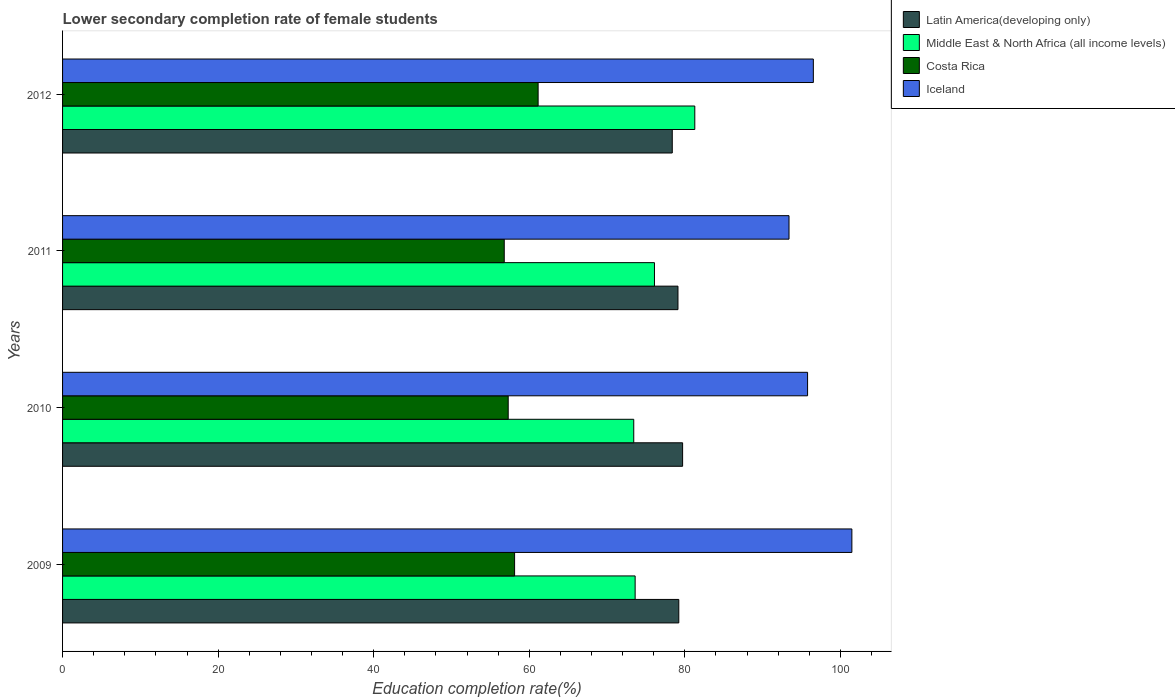How many different coloured bars are there?
Your answer should be compact. 4. How many groups of bars are there?
Make the answer very short. 4. Are the number of bars per tick equal to the number of legend labels?
Your response must be concise. Yes. Are the number of bars on each tick of the Y-axis equal?
Keep it short and to the point. Yes. How many bars are there on the 4th tick from the bottom?
Offer a very short reply. 4. What is the lower secondary completion rate of female students in Middle East & North Africa (all income levels) in 2011?
Ensure brevity in your answer.  76.1. Across all years, what is the maximum lower secondary completion rate of female students in Middle East & North Africa (all income levels)?
Make the answer very short. 81.29. Across all years, what is the minimum lower secondary completion rate of female students in Middle East & North Africa (all income levels)?
Your response must be concise. 73.44. In which year was the lower secondary completion rate of female students in Costa Rica maximum?
Offer a very short reply. 2012. In which year was the lower secondary completion rate of female students in Costa Rica minimum?
Offer a very short reply. 2011. What is the total lower secondary completion rate of female students in Costa Rica in the graph?
Offer a terse response. 233.34. What is the difference between the lower secondary completion rate of female students in Iceland in 2010 and that in 2012?
Provide a short and direct response. -0.74. What is the difference between the lower secondary completion rate of female students in Latin America(developing only) in 2010 and the lower secondary completion rate of female students in Costa Rica in 2011?
Provide a short and direct response. 22.93. What is the average lower secondary completion rate of female students in Iceland per year?
Ensure brevity in your answer.  96.8. In the year 2012, what is the difference between the lower secondary completion rate of female students in Latin America(developing only) and lower secondary completion rate of female students in Iceland?
Offer a very short reply. -18.14. What is the ratio of the lower secondary completion rate of female students in Latin America(developing only) in 2011 to that in 2012?
Provide a short and direct response. 1.01. Is the lower secondary completion rate of female students in Costa Rica in 2010 less than that in 2011?
Your answer should be compact. No. What is the difference between the highest and the second highest lower secondary completion rate of female students in Latin America(developing only)?
Your answer should be very brief. 0.49. What is the difference between the highest and the lowest lower secondary completion rate of female students in Middle East & North Africa (all income levels)?
Make the answer very short. 7.85. In how many years, is the lower secondary completion rate of female students in Middle East & North Africa (all income levels) greater than the average lower secondary completion rate of female students in Middle East & North Africa (all income levels) taken over all years?
Your response must be concise. 1. What does the 4th bar from the top in 2009 represents?
Your answer should be very brief. Latin America(developing only). How many years are there in the graph?
Your answer should be very brief. 4. What is the difference between two consecutive major ticks on the X-axis?
Provide a short and direct response. 20. Does the graph contain grids?
Provide a short and direct response. No. How many legend labels are there?
Offer a very short reply. 4. What is the title of the graph?
Your answer should be very brief. Lower secondary completion rate of female students. What is the label or title of the X-axis?
Offer a very short reply. Education completion rate(%). What is the label or title of the Y-axis?
Your response must be concise. Years. What is the Education completion rate(%) in Latin America(developing only) in 2009?
Make the answer very short. 79.23. What is the Education completion rate(%) of Middle East & North Africa (all income levels) in 2009?
Your answer should be very brief. 73.62. What is the Education completion rate(%) of Costa Rica in 2009?
Provide a short and direct response. 58.12. What is the Education completion rate(%) in Iceland in 2009?
Your answer should be very brief. 101.48. What is the Education completion rate(%) in Latin America(developing only) in 2010?
Ensure brevity in your answer.  79.72. What is the Education completion rate(%) in Middle East & North Africa (all income levels) in 2010?
Make the answer very short. 73.44. What is the Education completion rate(%) of Costa Rica in 2010?
Make the answer very short. 57.3. What is the Education completion rate(%) of Iceland in 2010?
Provide a succinct answer. 95.79. What is the Education completion rate(%) of Latin America(developing only) in 2011?
Provide a short and direct response. 79.12. What is the Education completion rate(%) in Middle East & North Africa (all income levels) in 2011?
Offer a very short reply. 76.1. What is the Education completion rate(%) in Costa Rica in 2011?
Provide a succinct answer. 56.79. What is the Education completion rate(%) in Iceland in 2011?
Your response must be concise. 93.4. What is the Education completion rate(%) of Latin America(developing only) in 2012?
Ensure brevity in your answer.  78.39. What is the Education completion rate(%) in Middle East & North Africa (all income levels) in 2012?
Your response must be concise. 81.29. What is the Education completion rate(%) of Costa Rica in 2012?
Your answer should be compact. 61.14. What is the Education completion rate(%) of Iceland in 2012?
Your answer should be very brief. 96.53. Across all years, what is the maximum Education completion rate(%) of Latin America(developing only)?
Your answer should be compact. 79.72. Across all years, what is the maximum Education completion rate(%) in Middle East & North Africa (all income levels)?
Provide a short and direct response. 81.29. Across all years, what is the maximum Education completion rate(%) in Costa Rica?
Keep it short and to the point. 61.14. Across all years, what is the maximum Education completion rate(%) in Iceland?
Provide a succinct answer. 101.48. Across all years, what is the minimum Education completion rate(%) of Latin America(developing only)?
Give a very brief answer. 78.39. Across all years, what is the minimum Education completion rate(%) of Middle East & North Africa (all income levels)?
Provide a succinct answer. 73.44. Across all years, what is the minimum Education completion rate(%) in Costa Rica?
Make the answer very short. 56.79. Across all years, what is the minimum Education completion rate(%) in Iceland?
Ensure brevity in your answer.  93.4. What is the total Education completion rate(%) in Latin America(developing only) in the graph?
Give a very brief answer. 316.46. What is the total Education completion rate(%) in Middle East & North Africa (all income levels) in the graph?
Keep it short and to the point. 304.44. What is the total Education completion rate(%) in Costa Rica in the graph?
Provide a short and direct response. 233.34. What is the total Education completion rate(%) of Iceland in the graph?
Ensure brevity in your answer.  387.19. What is the difference between the Education completion rate(%) of Latin America(developing only) in 2009 and that in 2010?
Give a very brief answer. -0.49. What is the difference between the Education completion rate(%) of Middle East & North Africa (all income levels) in 2009 and that in 2010?
Keep it short and to the point. 0.18. What is the difference between the Education completion rate(%) in Costa Rica in 2009 and that in 2010?
Offer a terse response. 0.82. What is the difference between the Education completion rate(%) in Iceland in 2009 and that in 2010?
Keep it short and to the point. 5.7. What is the difference between the Education completion rate(%) in Latin America(developing only) in 2009 and that in 2011?
Give a very brief answer. 0.11. What is the difference between the Education completion rate(%) of Middle East & North Africa (all income levels) in 2009 and that in 2011?
Provide a succinct answer. -2.48. What is the difference between the Education completion rate(%) in Costa Rica in 2009 and that in 2011?
Ensure brevity in your answer.  1.33. What is the difference between the Education completion rate(%) of Iceland in 2009 and that in 2011?
Ensure brevity in your answer.  8.08. What is the difference between the Education completion rate(%) of Latin America(developing only) in 2009 and that in 2012?
Offer a terse response. 0.84. What is the difference between the Education completion rate(%) of Middle East & North Africa (all income levels) in 2009 and that in 2012?
Provide a succinct answer. -7.67. What is the difference between the Education completion rate(%) of Costa Rica in 2009 and that in 2012?
Your response must be concise. -3.02. What is the difference between the Education completion rate(%) of Iceland in 2009 and that in 2012?
Provide a succinct answer. 4.95. What is the difference between the Education completion rate(%) of Latin America(developing only) in 2010 and that in 2011?
Your answer should be very brief. 0.6. What is the difference between the Education completion rate(%) in Middle East & North Africa (all income levels) in 2010 and that in 2011?
Your answer should be compact. -2.66. What is the difference between the Education completion rate(%) in Costa Rica in 2010 and that in 2011?
Offer a very short reply. 0.51. What is the difference between the Education completion rate(%) of Iceland in 2010 and that in 2011?
Provide a short and direct response. 2.39. What is the difference between the Education completion rate(%) of Latin America(developing only) in 2010 and that in 2012?
Ensure brevity in your answer.  1.33. What is the difference between the Education completion rate(%) in Middle East & North Africa (all income levels) in 2010 and that in 2012?
Offer a terse response. -7.85. What is the difference between the Education completion rate(%) in Costa Rica in 2010 and that in 2012?
Make the answer very short. -3.85. What is the difference between the Education completion rate(%) in Iceland in 2010 and that in 2012?
Offer a very short reply. -0.74. What is the difference between the Education completion rate(%) in Latin America(developing only) in 2011 and that in 2012?
Your answer should be compact. 0.73. What is the difference between the Education completion rate(%) of Middle East & North Africa (all income levels) in 2011 and that in 2012?
Your answer should be very brief. -5.19. What is the difference between the Education completion rate(%) of Costa Rica in 2011 and that in 2012?
Your answer should be compact. -4.35. What is the difference between the Education completion rate(%) in Iceland in 2011 and that in 2012?
Provide a short and direct response. -3.13. What is the difference between the Education completion rate(%) of Latin America(developing only) in 2009 and the Education completion rate(%) of Middle East & North Africa (all income levels) in 2010?
Keep it short and to the point. 5.79. What is the difference between the Education completion rate(%) of Latin America(developing only) in 2009 and the Education completion rate(%) of Costa Rica in 2010?
Keep it short and to the point. 21.93. What is the difference between the Education completion rate(%) in Latin America(developing only) in 2009 and the Education completion rate(%) in Iceland in 2010?
Offer a very short reply. -16.56. What is the difference between the Education completion rate(%) in Middle East & North Africa (all income levels) in 2009 and the Education completion rate(%) in Costa Rica in 2010?
Provide a short and direct response. 16.32. What is the difference between the Education completion rate(%) in Middle East & North Africa (all income levels) in 2009 and the Education completion rate(%) in Iceland in 2010?
Provide a short and direct response. -22.17. What is the difference between the Education completion rate(%) in Costa Rica in 2009 and the Education completion rate(%) in Iceland in 2010?
Offer a terse response. -37.67. What is the difference between the Education completion rate(%) in Latin America(developing only) in 2009 and the Education completion rate(%) in Middle East & North Africa (all income levels) in 2011?
Your response must be concise. 3.13. What is the difference between the Education completion rate(%) in Latin America(developing only) in 2009 and the Education completion rate(%) in Costa Rica in 2011?
Keep it short and to the point. 22.44. What is the difference between the Education completion rate(%) of Latin America(developing only) in 2009 and the Education completion rate(%) of Iceland in 2011?
Make the answer very short. -14.17. What is the difference between the Education completion rate(%) of Middle East & North Africa (all income levels) in 2009 and the Education completion rate(%) of Costa Rica in 2011?
Offer a very short reply. 16.83. What is the difference between the Education completion rate(%) in Middle East & North Africa (all income levels) in 2009 and the Education completion rate(%) in Iceland in 2011?
Provide a short and direct response. -19.78. What is the difference between the Education completion rate(%) in Costa Rica in 2009 and the Education completion rate(%) in Iceland in 2011?
Offer a terse response. -35.28. What is the difference between the Education completion rate(%) of Latin America(developing only) in 2009 and the Education completion rate(%) of Middle East & North Africa (all income levels) in 2012?
Offer a very short reply. -2.06. What is the difference between the Education completion rate(%) in Latin America(developing only) in 2009 and the Education completion rate(%) in Costa Rica in 2012?
Provide a succinct answer. 18.09. What is the difference between the Education completion rate(%) of Latin America(developing only) in 2009 and the Education completion rate(%) of Iceland in 2012?
Provide a succinct answer. -17.3. What is the difference between the Education completion rate(%) in Middle East & North Africa (all income levels) in 2009 and the Education completion rate(%) in Costa Rica in 2012?
Offer a very short reply. 12.47. What is the difference between the Education completion rate(%) of Middle East & North Africa (all income levels) in 2009 and the Education completion rate(%) of Iceland in 2012?
Ensure brevity in your answer.  -22.91. What is the difference between the Education completion rate(%) in Costa Rica in 2009 and the Education completion rate(%) in Iceland in 2012?
Offer a very short reply. -38.41. What is the difference between the Education completion rate(%) of Latin America(developing only) in 2010 and the Education completion rate(%) of Middle East & North Africa (all income levels) in 2011?
Make the answer very short. 3.62. What is the difference between the Education completion rate(%) in Latin America(developing only) in 2010 and the Education completion rate(%) in Costa Rica in 2011?
Offer a very short reply. 22.93. What is the difference between the Education completion rate(%) of Latin America(developing only) in 2010 and the Education completion rate(%) of Iceland in 2011?
Your answer should be compact. -13.68. What is the difference between the Education completion rate(%) of Middle East & North Africa (all income levels) in 2010 and the Education completion rate(%) of Costa Rica in 2011?
Make the answer very short. 16.65. What is the difference between the Education completion rate(%) of Middle East & North Africa (all income levels) in 2010 and the Education completion rate(%) of Iceland in 2011?
Offer a very short reply. -19.96. What is the difference between the Education completion rate(%) in Costa Rica in 2010 and the Education completion rate(%) in Iceland in 2011?
Provide a short and direct response. -36.1. What is the difference between the Education completion rate(%) in Latin America(developing only) in 2010 and the Education completion rate(%) in Middle East & North Africa (all income levels) in 2012?
Ensure brevity in your answer.  -1.57. What is the difference between the Education completion rate(%) in Latin America(developing only) in 2010 and the Education completion rate(%) in Costa Rica in 2012?
Ensure brevity in your answer.  18.58. What is the difference between the Education completion rate(%) in Latin America(developing only) in 2010 and the Education completion rate(%) in Iceland in 2012?
Offer a very short reply. -16.81. What is the difference between the Education completion rate(%) of Middle East & North Africa (all income levels) in 2010 and the Education completion rate(%) of Costa Rica in 2012?
Give a very brief answer. 12.29. What is the difference between the Education completion rate(%) of Middle East & North Africa (all income levels) in 2010 and the Education completion rate(%) of Iceland in 2012?
Keep it short and to the point. -23.09. What is the difference between the Education completion rate(%) in Costa Rica in 2010 and the Education completion rate(%) in Iceland in 2012?
Provide a short and direct response. -39.23. What is the difference between the Education completion rate(%) in Latin America(developing only) in 2011 and the Education completion rate(%) in Middle East & North Africa (all income levels) in 2012?
Offer a terse response. -2.16. What is the difference between the Education completion rate(%) of Latin America(developing only) in 2011 and the Education completion rate(%) of Costa Rica in 2012?
Your response must be concise. 17.98. What is the difference between the Education completion rate(%) of Latin America(developing only) in 2011 and the Education completion rate(%) of Iceland in 2012?
Offer a very short reply. -17.41. What is the difference between the Education completion rate(%) of Middle East & North Africa (all income levels) in 2011 and the Education completion rate(%) of Costa Rica in 2012?
Provide a succinct answer. 14.96. What is the difference between the Education completion rate(%) of Middle East & North Africa (all income levels) in 2011 and the Education completion rate(%) of Iceland in 2012?
Offer a very short reply. -20.43. What is the difference between the Education completion rate(%) in Costa Rica in 2011 and the Education completion rate(%) in Iceland in 2012?
Your answer should be compact. -39.74. What is the average Education completion rate(%) in Latin America(developing only) per year?
Provide a short and direct response. 79.12. What is the average Education completion rate(%) of Middle East & North Africa (all income levels) per year?
Your answer should be compact. 76.11. What is the average Education completion rate(%) of Costa Rica per year?
Offer a terse response. 58.34. What is the average Education completion rate(%) of Iceland per year?
Your response must be concise. 96.8. In the year 2009, what is the difference between the Education completion rate(%) of Latin America(developing only) and Education completion rate(%) of Middle East & North Africa (all income levels)?
Keep it short and to the point. 5.61. In the year 2009, what is the difference between the Education completion rate(%) of Latin America(developing only) and Education completion rate(%) of Costa Rica?
Make the answer very short. 21.11. In the year 2009, what is the difference between the Education completion rate(%) of Latin America(developing only) and Education completion rate(%) of Iceland?
Keep it short and to the point. -22.25. In the year 2009, what is the difference between the Education completion rate(%) of Middle East & North Africa (all income levels) and Education completion rate(%) of Costa Rica?
Provide a succinct answer. 15.5. In the year 2009, what is the difference between the Education completion rate(%) in Middle East & North Africa (all income levels) and Education completion rate(%) in Iceland?
Provide a succinct answer. -27.86. In the year 2009, what is the difference between the Education completion rate(%) of Costa Rica and Education completion rate(%) of Iceland?
Offer a terse response. -43.36. In the year 2010, what is the difference between the Education completion rate(%) of Latin America(developing only) and Education completion rate(%) of Middle East & North Africa (all income levels)?
Provide a succinct answer. 6.28. In the year 2010, what is the difference between the Education completion rate(%) in Latin America(developing only) and Education completion rate(%) in Costa Rica?
Provide a succinct answer. 22.42. In the year 2010, what is the difference between the Education completion rate(%) in Latin America(developing only) and Education completion rate(%) in Iceland?
Make the answer very short. -16.07. In the year 2010, what is the difference between the Education completion rate(%) in Middle East & North Africa (all income levels) and Education completion rate(%) in Costa Rica?
Provide a succinct answer. 16.14. In the year 2010, what is the difference between the Education completion rate(%) of Middle East & North Africa (all income levels) and Education completion rate(%) of Iceland?
Provide a succinct answer. -22.35. In the year 2010, what is the difference between the Education completion rate(%) of Costa Rica and Education completion rate(%) of Iceland?
Provide a short and direct response. -38.49. In the year 2011, what is the difference between the Education completion rate(%) of Latin America(developing only) and Education completion rate(%) of Middle East & North Africa (all income levels)?
Ensure brevity in your answer.  3.02. In the year 2011, what is the difference between the Education completion rate(%) in Latin America(developing only) and Education completion rate(%) in Costa Rica?
Your answer should be compact. 22.33. In the year 2011, what is the difference between the Education completion rate(%) in Latin America(developing only) and Education completion rate(%) in Iceland?
Offer a very short reply. -14.28. In the year 2011, what is the difference between the Education completion rate(%) in Middle East & North Africa (all income levels) and Education completion rate(%) in Costa Rica?
Keep it short and to the point. 19.31. In the year 2011, what is the difference between the Education completion rate(%) in Middle East & North Africa (all income levels) and Education completion rate(%) in Iceland?
Offer a very short reply. -17.3. In the year 2011, what is the difference between the Education completion rate(%) in Costa Rica and Education completion rate(%) in Iceland?
Keep it short and to the point. -36.61. In the year 2012, what is the difference between the Education completion rate(%) in Latin America(developing only) and Education completion rate(%) in Middle East & North Africa (all income levels)?
Ensure brevity in your answer.  -2.9. In the year 2012, what is the difference between the Education completion rate(%) of Latin America(developing only) and Education completion rate(%) of Costa Rica?
Your answer should be very brief. 17.25. In the year 2012, what is the difference between the Education completion rate(%) of Latin America(developing only) and Education completion rate(%) of Iceland?
Ensure brevity in your answer.  -18.14. In the year 2012, what is the difference between the Education completion rate(%) of Middle East & North Africa (all income levels) and Education completion rate(%) of Costa Rica?
Ensure brevity in your answer.  20.15. In the year 2012, what is the difference between the Education completion rate(%) of Middle East & North Africa (all income levels) and Education completion rate(%) of Iceland?
Offer a very short reply. -15.24. In the year 2012, what is the difference between the Education completion rate(%) of Costa Rica and Education completion rate(%) of Iceland?
Your answer should be compact. -35.39. What is the ratio of the Education completion rate(%) of Latin America(developing only) in 2009 to that in 2010?
Make the answer very short. 0.99. What is the ratio of the Education completion rate(%) of Costa Rica in 2009 to that in 2010?
Give a very brief answer. 1.01. What is the ratio of the Education completion rate(%) in Iceland in 2009 to that in 2010?
Offer a terse response. 1.06. What is the ratio of the Education completion rate(%) of Middle East & North Africa (all income levels) in 2009 to that in 2011?
Your answer should be compact. 0.97. What is the ratio of the Education completion rate(%) in Costa Rica in 2009 to that in 2011?
Your answer should be compact. 1.02. What is the ratio of the Education completion rate(%) in Iceland in 2009 to that in 2011?
Provide a short and direct response. 1.09. What is the ratio of the Education completion rate(%) in Latin America(developing only) in 2009 to that in 2012?
Offer a terse response. 1.01. What is the ratio of the Education completion rate(%) in Middle East & North Africa (all income levels) in 2009 to that in 2012?
Give a very brief answer. 0.91. What is the ratio of the Education completion rate(%) in Costa Rica in 2009 to that in 2012?
Make the answer very short. 0.95. What is the ratio of the Education completion rate(%) of Iceland in 2009 to that in 2012?
Provide a short and direct response. 1.05. What is the ratio of the Education completion rate(%) in Latin America(developing only) in 2010 to that in 2011?
Your answer should be very brief. 1.01. What is the ratio of the Education completion rate(%) of Middle East & North Africa (all income levels) in 2010 to that in 2011?
Keep it short and to the point. 0.96. What is the ratio of the Education completion rate(%) of Costa Rica in 2010 to that in 2011?
Your answer should be very brief. 1.01. What is the ratio of the Education completion rate(%) of Iceland in 2010 to that in 2011?
Ensure brevity in your answer.  1.03. What is the ratio of the Education completion rate(%) of Latin America(developing only) in 2010 to that in 2012?
Your response must be concise. 1.02. What is the ratio of the Education completion rate(%) in Middle East & North Africa (all income levels) in 2010 to that in 2012?
Offer a terse response. 0.9. What is the ratio of the Education completion rate(%) in Costa Rica in 2010 to that in 2012?
Your answer should be compact. 0.94. What is the ratio of the Education completion rate(%) of Iceland in 2010 to that in 2012?
Your answer should be very brief. 0.99. What is the ratio of the Education completion rate(%) in Latin America(developing only) in 2011 to that in 2012?
Ensure brevity in your answer.  1.01. What is the ratio of the Education completion rate(%) in Middle East & North Africa (all income levels) in 2011 to that in 2012?
Provide a short and direct response. 0.94. What is the ratio of the Education completion rate(%) of Costa Rica in 2011 to that in 2012?
Make the answer very short. 0.93. What is the ratio of the Education completion rate(%) in Iceland in 2011 to that in 2012?
Keep it short and to the point. 0.97. What is the difference between the highest and the second highest Education completion rate(%) of Latin America(developing only)?
Provide a short and direct response. 0.49. What is the difference between the highest and the second highest Education completion rate(%) of Middle East & North Africa (all income levels)?
Your answer should be compact. 5.19. What is the difference between the highest and the second highest Education completion rate(%) of Costa Rica?
Keep it short and to the point. 3.02. What is the difference between the highest and the second highest Education completion rate(%) in Iceland?
Give a very brief answer. 4.95. What is the difference between the highest and the lowest Education completion rate(%) of Latin America(developing only)?
Provide a succinct answer. 1.33. What is the difference between the highest and the lowest Education completion rate(%) of Middle East & North Africa (all income levels)?
Make the answer very short. 7.85. What is the difference between the highest and the lowest Education completion rate(%) in Costa Rica?
Make the answer very short. 4.35. What is the difference between the highest and the lowest Education completion rate(%) in Iceland?
Ensure brevity in your answer.  8.08. 